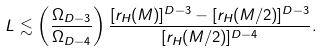Convert formula to latex. <formula><loc_0><loc_0><loc_500><loc_500>L \lesssim \left ( \frac { \Omega _ { D - 3 } } { \Omega _ { D - 4 } } \right ) \frac { [ r _ { H } ( M ) ] ^ { D - 3 } - [ r _ { H } ( M / 2 ) ] ^ { D - 3 } } { [ r _ { H } ( M / 2 ) ] ^ { D - 4 } } .</formula> 